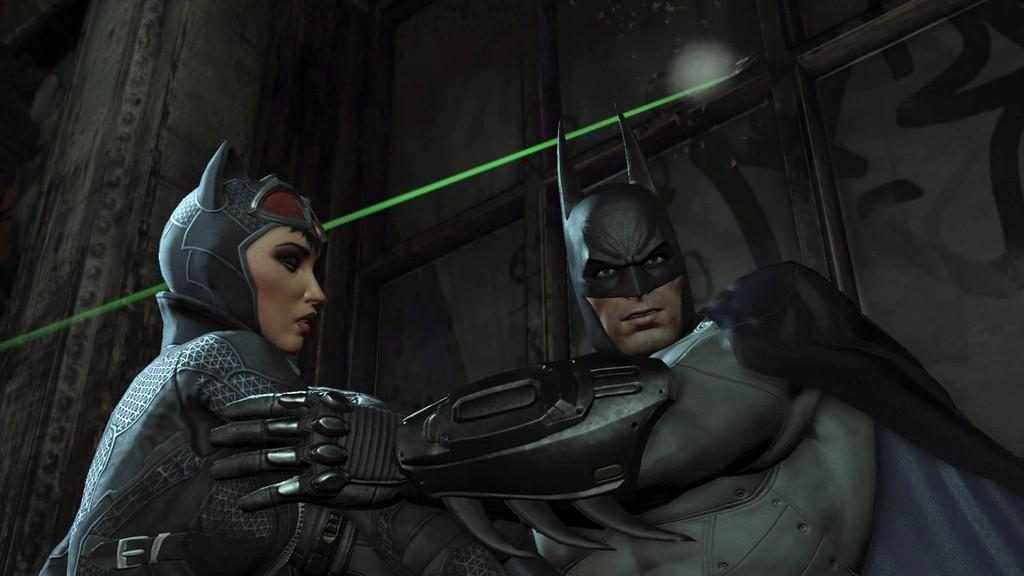How would you summarize this image in a sentence or two? Here we can see animated people. Background there is a wall. 